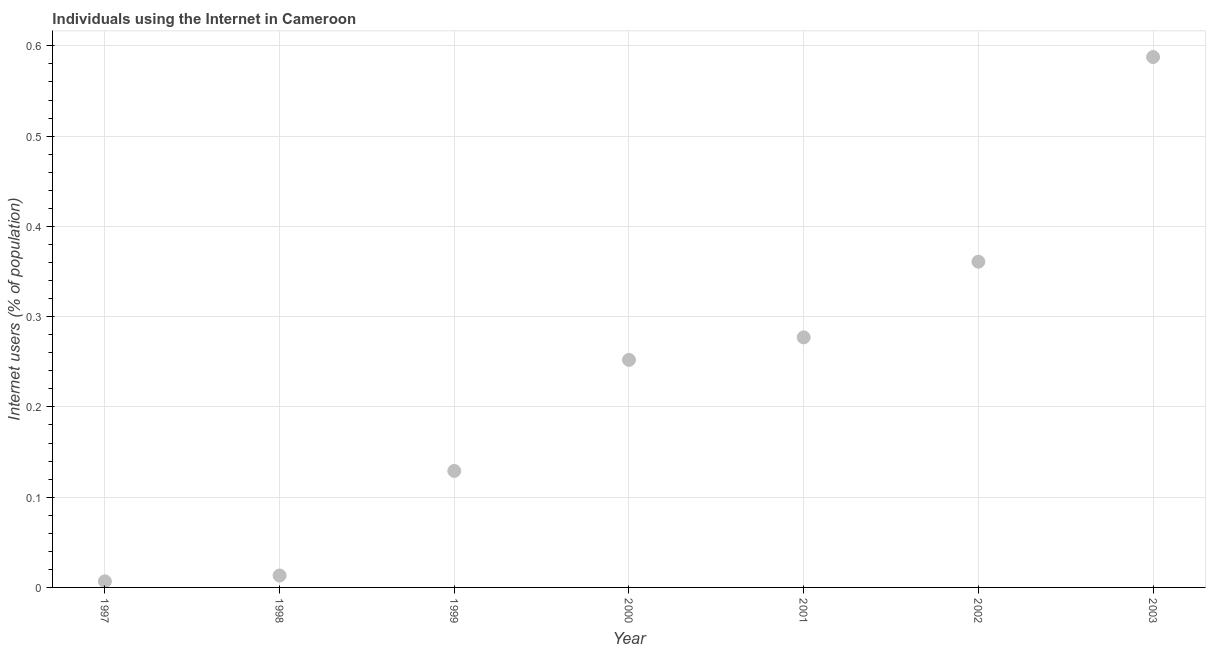What is the number of internet users in 1998?
Offer a very short reply. 0.01. Across all years, what is the maximum number of internet users?
Make the answer very short. 0.59. Across all years, what is the minimum number of internet users?
Offer a terse response. 0.01. In which year was the number of internet users maximum?
Your response must be concise. 2003. What is the sum of the number of internet users?
Your response must be concise. 1.63. What is the difference between the number of internet users in 1997 and 1998?
Provide a succinct answer. -0.01. What is the average number of internet users per year?
Your answer should be very brief. 0.23. What is the median number of internet users?
Provide a short and direct response. 0.25. Do a majority of the years between 2000 and 1997 (inclusive) have number of internet users greater than 0.18 %?
Make the answer very short. Yes. What is the ratio of the number of internet users in 1997 to that in 2001?
Keep it short and to the point. 0.02. Is the number of internet users in 2000 less than that in 2003?
Keep it short and to the point. Yes. Is the difference between the number of internet users in 1998 and 2000 greater than the difference between any two years?
Your answer should be very brief. No. What is the difference between the highest and the second highest number of internet users?
Your response must be concise. 0.23. What is the difference between the highest and the lowest number of internet users?
Give a very brief answer. 0.58. In how many years, is the number of internet users greater than the average number of internet users taken over all years?
Make the answer very short. 4. Are the values on the major ticks of Y-axis written in scientific E-notation?
Provide a succinct answer. No. Does the graph contain any zero values?
Make the answer very short. No. Does the graph contain grids?
Offer a very short reply. Yes. What is the title of the graph?
Give a very brief answer. Individuals using the Internet in Cameroon. What is the label or title of the Y-axis?
Make the answer very short. Internet users (% of population). What is the Internet users (% of population) in 1997?
Keep it short and to the point. 0.01. What is the Internet users (% of population) in 1998?
Offer a very short reply. 0.01. What is the Internet users (% of population) in 1999?
Offer a very short reply. 0.13. What is the Internet users (% of population) in 2000?
Give a very brief answer. 0.25. What is the Internet users (% of population) in 2001?
Your answer should be compact. 0.28. What is the Internet users (% of population) in 2002?
Make the answer very short. 0.36. What is the Internet users (% of population) in 2003?
Offer a very short reply. 0.59. What is the difference between the Internet users (% of population) in 1997 and 1998?
Provide a short and direct response. -0.01. What is the difference between the Internet users (% of population) in 1997 and 1999?
Keep it short and to the point. -0.12. What is the difference between the Internet users (% of population) in 1997 and 2000?
Offer a terse response. -0.25. What is the difference between the Internet users (% of population) in 1997 and 2001?
Your response must be concise. -0.27. What is the difference between the Internet users (% of population) in 1997 and 2002?
Provide a succinct answer. -0.35. What is the difference between the Internet users (% of population) in 1997 and 2003?
Ensure brevity in your answer.  -0.58. What is the difference between the Internet users (% of population) in 1998 and 1999?
Give a very brief answer. -0.12. What is the difference between the Internet users (% of population) in 1998 and 2000?
Offer a very short reply. -0.24. What is the difference between the Internet users (% of population) in 1998 and 2001?
Offer a very short reply. -0.26. What is the difference between the Internet users (% of population) in 1998 and 2002?
Ensure brevity in your answer.  -0.35. What is the difference between the Internet users (% of population) in 1998 and 2003?
Your answer should be very brief. -0.57. What is the difference between the Internet users (% of population) in 1999 and 2000?
Offer a very short reply. -0.12. What is the difference between the Internet users (% of population) in 1999 and 2001?
Make the answer very short. -0.15. What is the difference between the Internet users (% of population) in 1999 and 2002?
Ensure brevity in your answer.  -0.23. What is the difference between the Internet users (% of population) in 1999 and 2003?
Make the answer very short. -0.46. What is the difference between the Internet users (% of population) in 2000 and 2001?
Provide a succinct answer. -0.02. What is the difference between the Internet users (% of population) in 2000 and 2002?
Make the answer very short. -0.11. What is the difference between the Internet users (% of population) in 2000 and 2003?
Ensure brevity in your answer.  -0.34. What is the difference between the Internet users (% of population) in 2001 and 2002?
Your answer should be very brief. -0.08. What is the difference between the Internet users (% of population) in 2001 and 2003?
Your answer should be very brief. -0.31. What is the difference between the Internet users (% of population) in 2002 and 2003?
Your answer should be very brief. -0.23. What is the ratio of the Internet users (% of population) in 1997 to that in 1998?
Your response must be concise. 0.51. What is the ratio of the Internet users (% of population) in 1997 to that in 1999?
Provide a short and direct response. 0.05. What is the ratio of the Internet users (% of population) in 1997 to that in 2000?
Ensure brevity in your answer.  0.03. What is the ratio of the Internet users (% of population) in 1997 to that in 2001?
Keep it short and to the point. 0.02. What is the ratio of the Internet users (% of population) in 1997 to that in 2002?
Provide a succinct answer. 0.02. What is the ratio of the Internet users (% of population) in 1997 to that in 2003?
Provide a short and direct response. 0.01. What is the ratio of the Internet users (% of population) in 1998 to that in 1999?
Provide a succinct answer. 0.1. What is the ratio of the Internet users (% of population) in 1998 to that in 2000?
Offer a terse response. 0.05. What is the ratio of the Internet users (% of population) in 1998 to that in 2001?
Your answer should be compact. 0.05. What is the ratio of the Internet users (% of population) in 1998 to that in 2002?
Your response must be concise. 0.04. What is the ratio of the Internet users (% of population) in 1998 to that in 2003?
Provide a short and direct response. 0.02. What is the ratio of the Internet users (% of population) in 1999 to that in 2000?
Your answer should be compact. 0.51. What is the ratio of the Internet users (% of population) in 1999 to that in 2001?
Offer a very short reply. 0.47. What is the ratio of the Internet users (% of population) in 1999 to that in 2002?
Your response must be concise. 0.36. What is the ratio of the Internet users (% of population) in 1999 to that in 2003?
Ensure brevity in your answer.  0.22. What is the ratio of the Internet users (% of population) in 2000 to that in 2001?
Provide a short and direct response. 0.91. What is the ratio of the Internet users (% of population) in 2000 to that in 2002?
Your answer should be compact. 0.7. What is the ratio of the Internet users (% of population) in 2000 to that in 2003?
Your response must be concise. 0.43. What is the ratio of the Internet users (% of population) in 2001 to that in 2002?
Give a very brief answer. 0.77. What is the ratio of the Internet users (% of population) in 2001 to that in 2003?
Ensure brevity in your answer.  0.47. What is the ratio of the Internet users (% of population) in 2002 to that in 2003?
Your response must be concise. 0.61. 